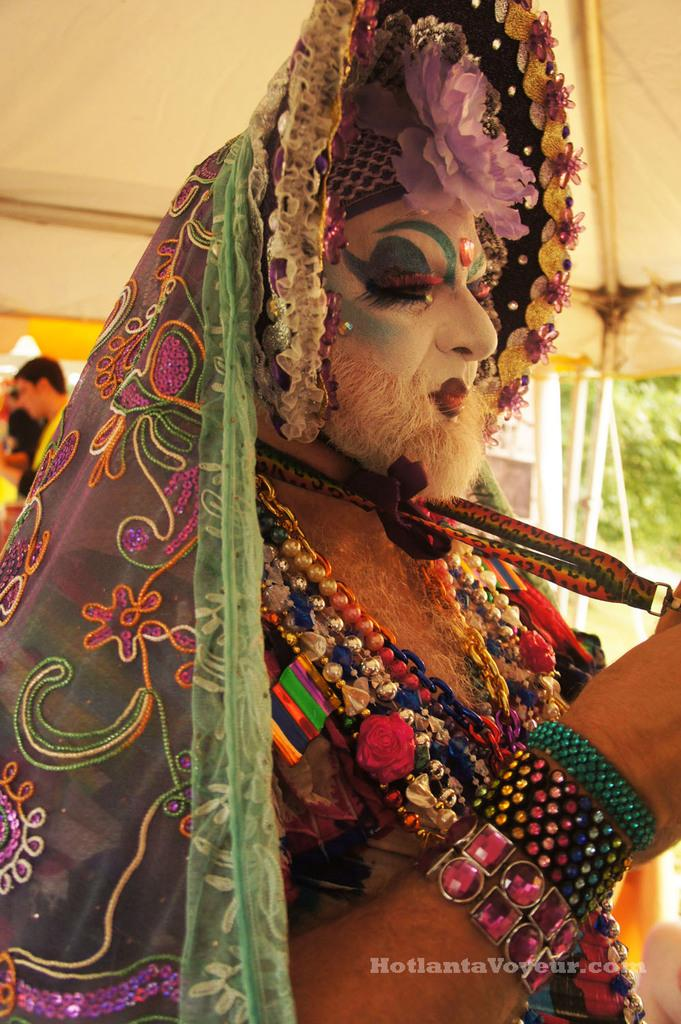Who is present in the image? There is a man in the image. What is the man wearing? The man is wearing a costume. Where is the man standing in the image? The man is standing under a tent. What can be found in the bottom right corner of the image? There is text in the bottom right corner of the image. What type of rock is the man holding in the image? There is no rock present in the image; the man is wearing a costume and standing under a tent. Can you see any flames in the image? There are no flames visible in the image. 